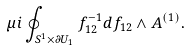<formula> <loc_0><loc_0><loc_500><loc_500>\mu i \oint _ { S ^ { 1 } \times \partial U _ { 1 } } f _ { 1 2 } ^ { - 1 } d f _ { 1 2 } \wedge A ^ { ( 1 ) } .</formula> 